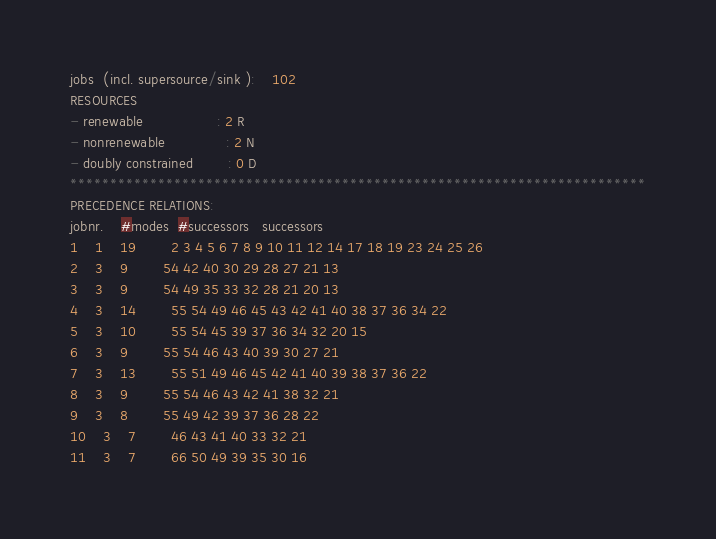Convert code to text. <code><loc_0><loc_0><loc_500><loc_500><_ObjectiveC_>jobs  (incl. supersource/sink ):	102
RESOURCES
- renewable                 : 2 R
- nonrenewable              : 2 N
- doubly constrained        : 0 D
************************************************************************
PRECEDENCE RELATIONS:
jobnr.    #modes  #successors   successors
1	1	19		2 3 4 5 6 7 8 9 10 11 12 14 17 18 19 23 24 25 26 
2	3	9		54 42 40 30 29 28 27 21 13 
3	3	9		54 49 35 33 32 28 21 20 13 
4	3	14		55 54 49 46 45 43 42 41 40 38 37 36 34 22 
5	3	10		55 54 45 39 37 36 34 32 20 15 
6	3	9		55 54 46 43 40 39 30 27 21 
7	3	13		55 51 49 46 45 42 41 40 39 38 37 36 22 
8	3	9		55 54 46 43 42 41 38 32 21 
9	3	8		55 49 42 39 37 36 28 22 
10	3	7		46 43 41 40 33 32 21 
11	3	7		66 50 49 39 35 30 16 </code> 